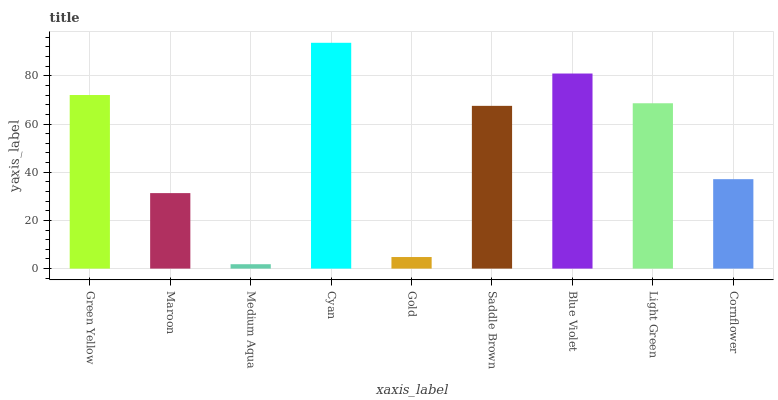Is Medium Aqua the minimum?
Answer yes or no. Yes. Is Cyan the maximum?
Answer yes or no. Yes. Is Maroon the minimum?
Answer yes or no. No. Is Maroon the maximum?
Answer yes or no. No. Is Green Yellow greater than Maroon?
Answer yes or no. Yes. Is Maroon less than Green Yellow?
Answer yes or no. Yes. Is Maroon greater than Green Yellow?
Answer yes or no. No. Is Green Yellow less than Maroon?
Answer yes or no. No. Is Saddle Brown the high median?
Answer yes or no. Yes. Is Saddle Brown the low median?
Answer yes or no. Yes. Is Gold the high median?
Answer yes or no. No. Is Green Yellow the low median?
Answer yes or no. No. 